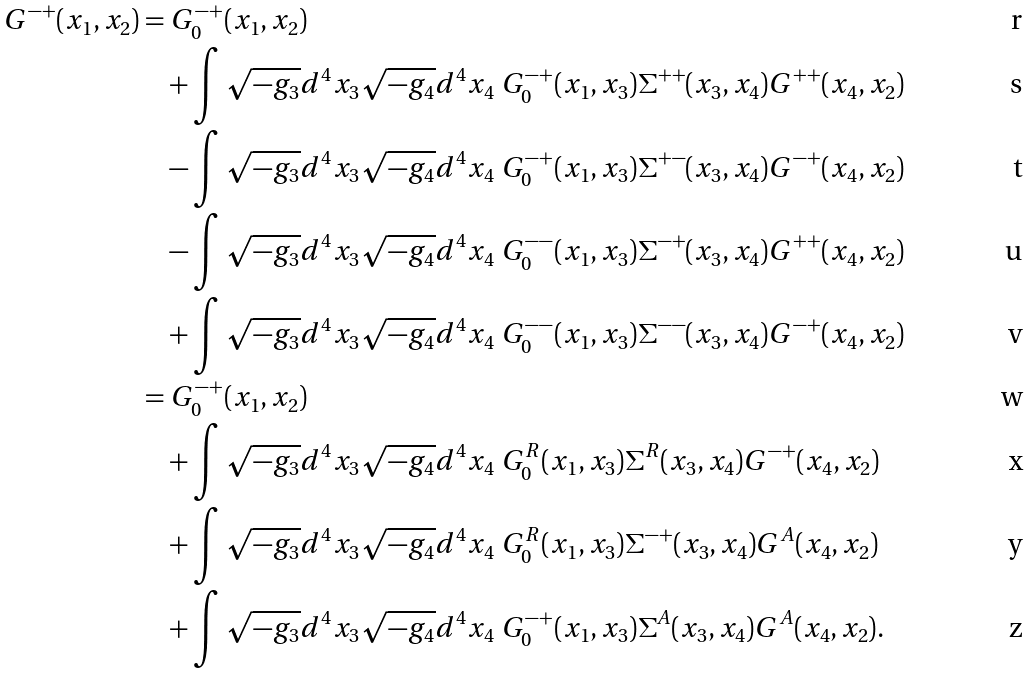<formula> <loc_0><loc_0><loc_500><loc_500>G ^ { - + } ( x _ { 1 } , x _ { 2 } ) = & \ G _ { 0 } ^ { - + } ( x _ { 1 } , x _ { 2 } ) \\ & + \int \sqrt { - g _ { 3 } } d ^ { 4 } x _ { 3 } \sqrt { - g _ { 4 } } d ^ { 4 } x _ { 4 } \ G _ { 0 } ^ { - + } ( x _ { 1 } , x _ { 3 } ) \Sigma ^ { + + } ( x _ { 3 } , x _ { 4 } ) G ^ { + + } ( x _ { 4 } , x _ { 2 } ) \\ & - \int \sqrt { - g _ { 3 } } d ^ { 4 } x _ { 3 } \sqrt { - g _ { 4 } } d ^ { 4 } x _ { 4 } \ G _ { 0 } ^ { - + } ( x _ { 1 } , x _ { 3 } ) \Sigma ^ { + - } ( x _ { 3 } , x _ { 4 } ) G ^ { - + } ( x _ { 4 } , x _ { 2 } ) \\ & - \int \sqrt { - g _ { 3 } } d ^ { 4 } x _ { 3 } \sqrt { - g _ { 4 } } d ^ { 4 } x _ { 4 } \ G _ { 0 } ^ { - - } ( x _ { 1 } , x _ { 3 } ) \Sigma ^ { - + } ( x _ { 3 } , x _ { 4 } ) G ^ { + + } ( x _ { 4 } , x _ { 2 } ) \\ & + \int \sqrt { - g _ { 3 } } d ^ { 4 } x _ { 3 } \sqrt { - g _ { 4 } } d ^ { 4 } x _ { 4 } \ G _ { 0 } ^ { - - } ( x _ { 1 } , x _ { 3 } ) \Sigma ^ { - - } ( x _ { 3 } , x _ { 4 } ) G ^ { - + } ( x _ { 4 } , x _ { 2 } ) \\ = & \ G ^ { - + } _ { 0 } ( x _ { 1 } , x _ { 2 } ) \\ & + \int \sqrt { - g _ { 3 } } d ^ { 4 } x _ { 3 } \sqrt { - g _ { 4 } } d ^ { 4 } x _ { 4 } \ G _ { 0 } ^ { R } ( x _ { 1 } , x _ { 3 } ) \Sigma ^ { R } ( x _ { 3 } , x _ { 4 } ) G ^ { - + } ( x _ { 4 } , x _ { 2 } ) \\ & + \int \sqrt { - g _ { 3 } } d ^ { 4 } x _ { 3 } \sqrt { - g _ { 4 } } d ^ { 4 } x _ { 4 } \ G _ { 0 } ^ { R } ( x _ { 1 } , x _ { 3 } ) \Sigma ^ { - + } ( x _ { 3 } , x _ { 4 } ) G ^ { A } ( x _ { 4 } , x _ { 2 } ) \\ & + \int \sqrt { - g _ { 3 } } d ^ { 4 } x _ { 3 } \sqrt { - g _ { 4 } } d ^ { 4 } x _ { 4 } \ G _ { 0 } ^ { - + } ( x _ { 1 } , x _ { 3 } ) \Sigma ^ { A } ( x _ { 3 } , x _ { 4 } ) G ^ { A } ( x _ { 4 } , x _ { 2 } ) .</formula> 